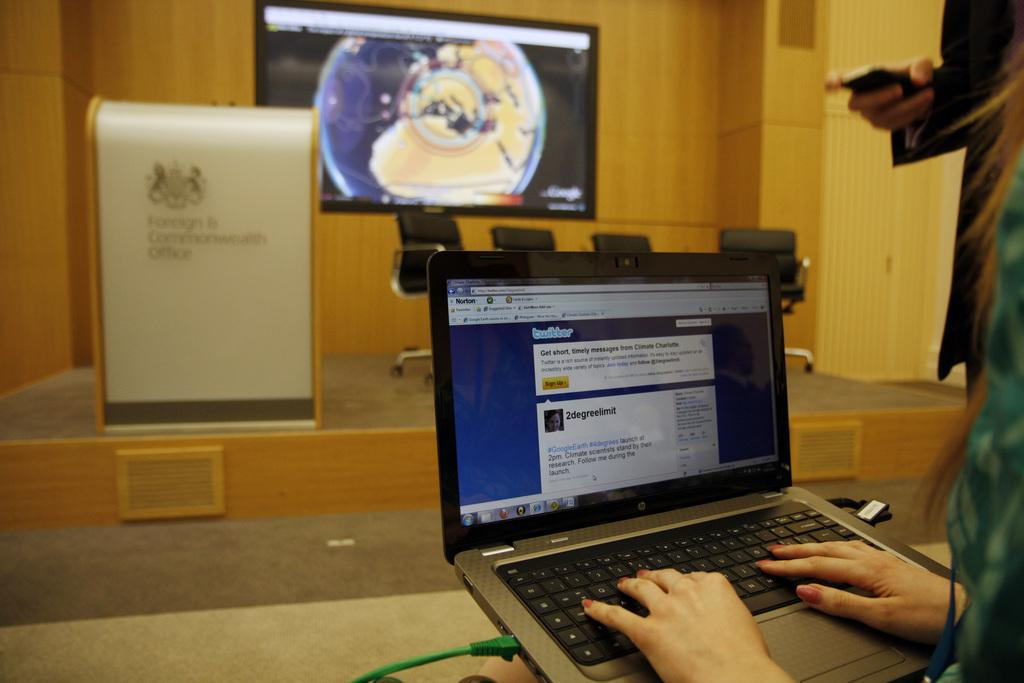<image>
Provide a brief description of the given image. A woman on a laptop computer with a web page open to Twitter. 